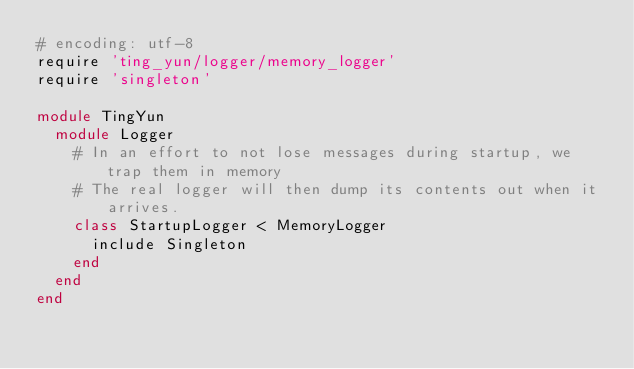<code> <loc_0><loc_0><loc_500><loc_500><_Ruby_># encoding: utf-8
require 'ting_yun/logger/memory_logger'
require 'singleton'

module TingYun
  module Logger
    # In an effort to not lose messages during startup, we trap them in memory
    # The real logger will then dump its contents out when it arrives.
    class StartupLogger < MemoryLogger
      include Singleton
    end
  end
end</code> 